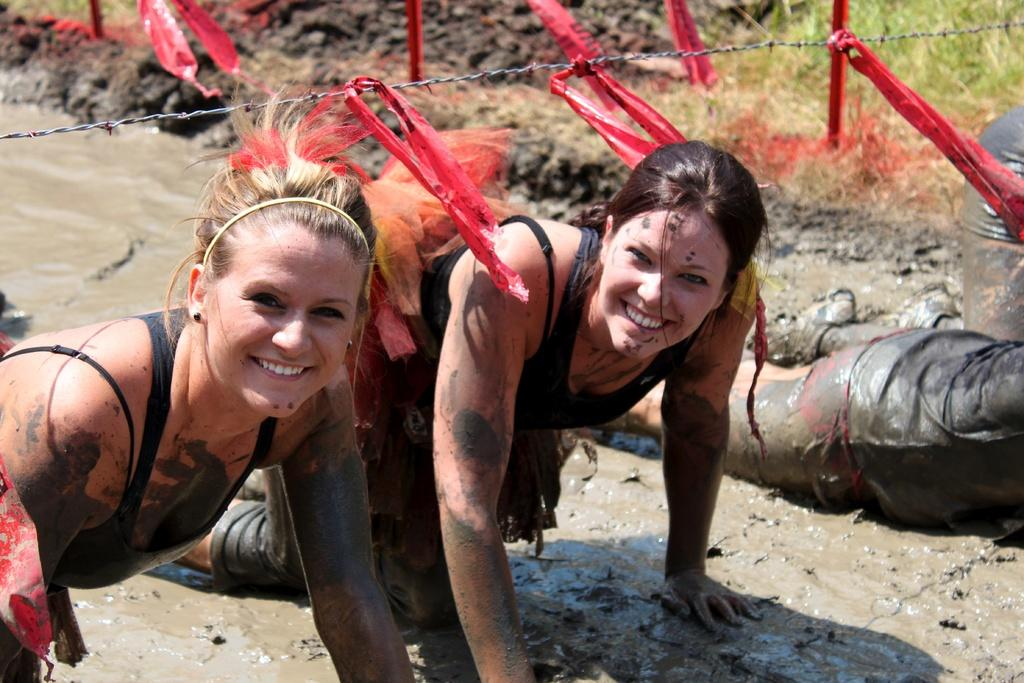How many people are in the image? There are four persons in the image. What are the persons doing in the image? The persons are playing in mud. Can you describe any other elements in the image? There is a wire visible in the image. What type of eggnog can be seen in the image? There is no eggnog present in the image; the persons are playing in mud. What is the birth rate of the persons in the image? The birth rate of the persons cannot be determined from the image, as it only shows them playing in mud. 